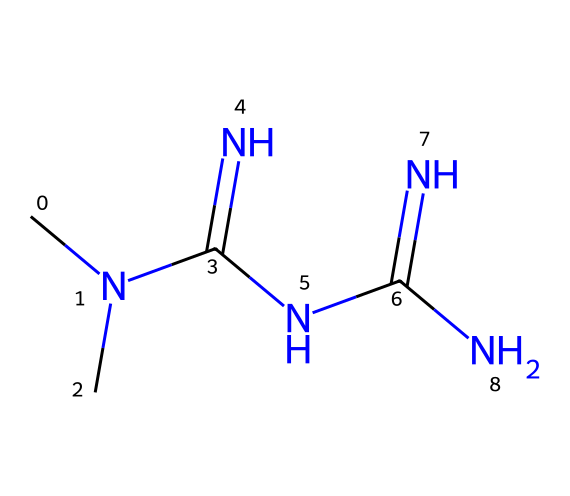What is the molecular formula of Metformin? By interpreting the SMILES representation, we can identify the types and quantities of atoms present. The SMILES indicates the presence of carbon (C), nitrogen (N), and hydrogen (H) atoms, leading us to the molecular formula.
Answer: C4H11N5 How many nitrogen atoms are present in Metformin? The SMILES representation shows multiple "N" symbols, which indicate the presence of these nitrogen atoms. Counting them, we find there are five nitrogen atoms.
Answer: 5 What type of drug is Metformin classified as? Metformin is commonly classified as a biguanide. This classification is based on its chemical structure and function in treating diabetes.
Answer: biguanide Which functional groups can be identified in Metformin? Examining the structure and SMILES reveals the presence of amino groups (-NH) and imine functionality (C=N). These functionalities are significant for the drug's action.
Answer: amino, imine What is Metformin primarily used to treat? Metformin is primarily used to treat type 2 diabetes. This usage is determined by its mechanism of action, which helps improve insulin sensitivity and lower blood sugar levels.
Answer: type 2 diabetes How does Metformin act on blood sugar levels? Metformin primarily reduces hepatic glucose production and enhances peripheral glucose uptake. These dual mechanisms contribute to its effectiveness in managing blood sugar.
Answer: reduces glucose production 